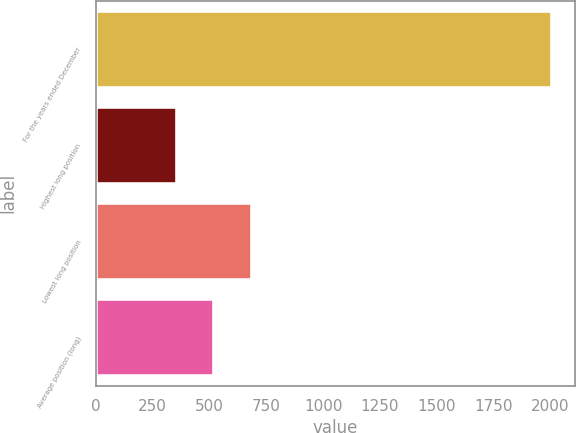Convert chart to OTSL. <chart><loc_0><loc_0><loc_500><loc_500><bar_chart><fcel>For the years ended December<fcel>Highest long position<fcel>Lowest long position<fcel>Average position (long)<nl><fcel>2008<fcel>357.1<fcel>687.28<fcel>522.19<nl></chart> 